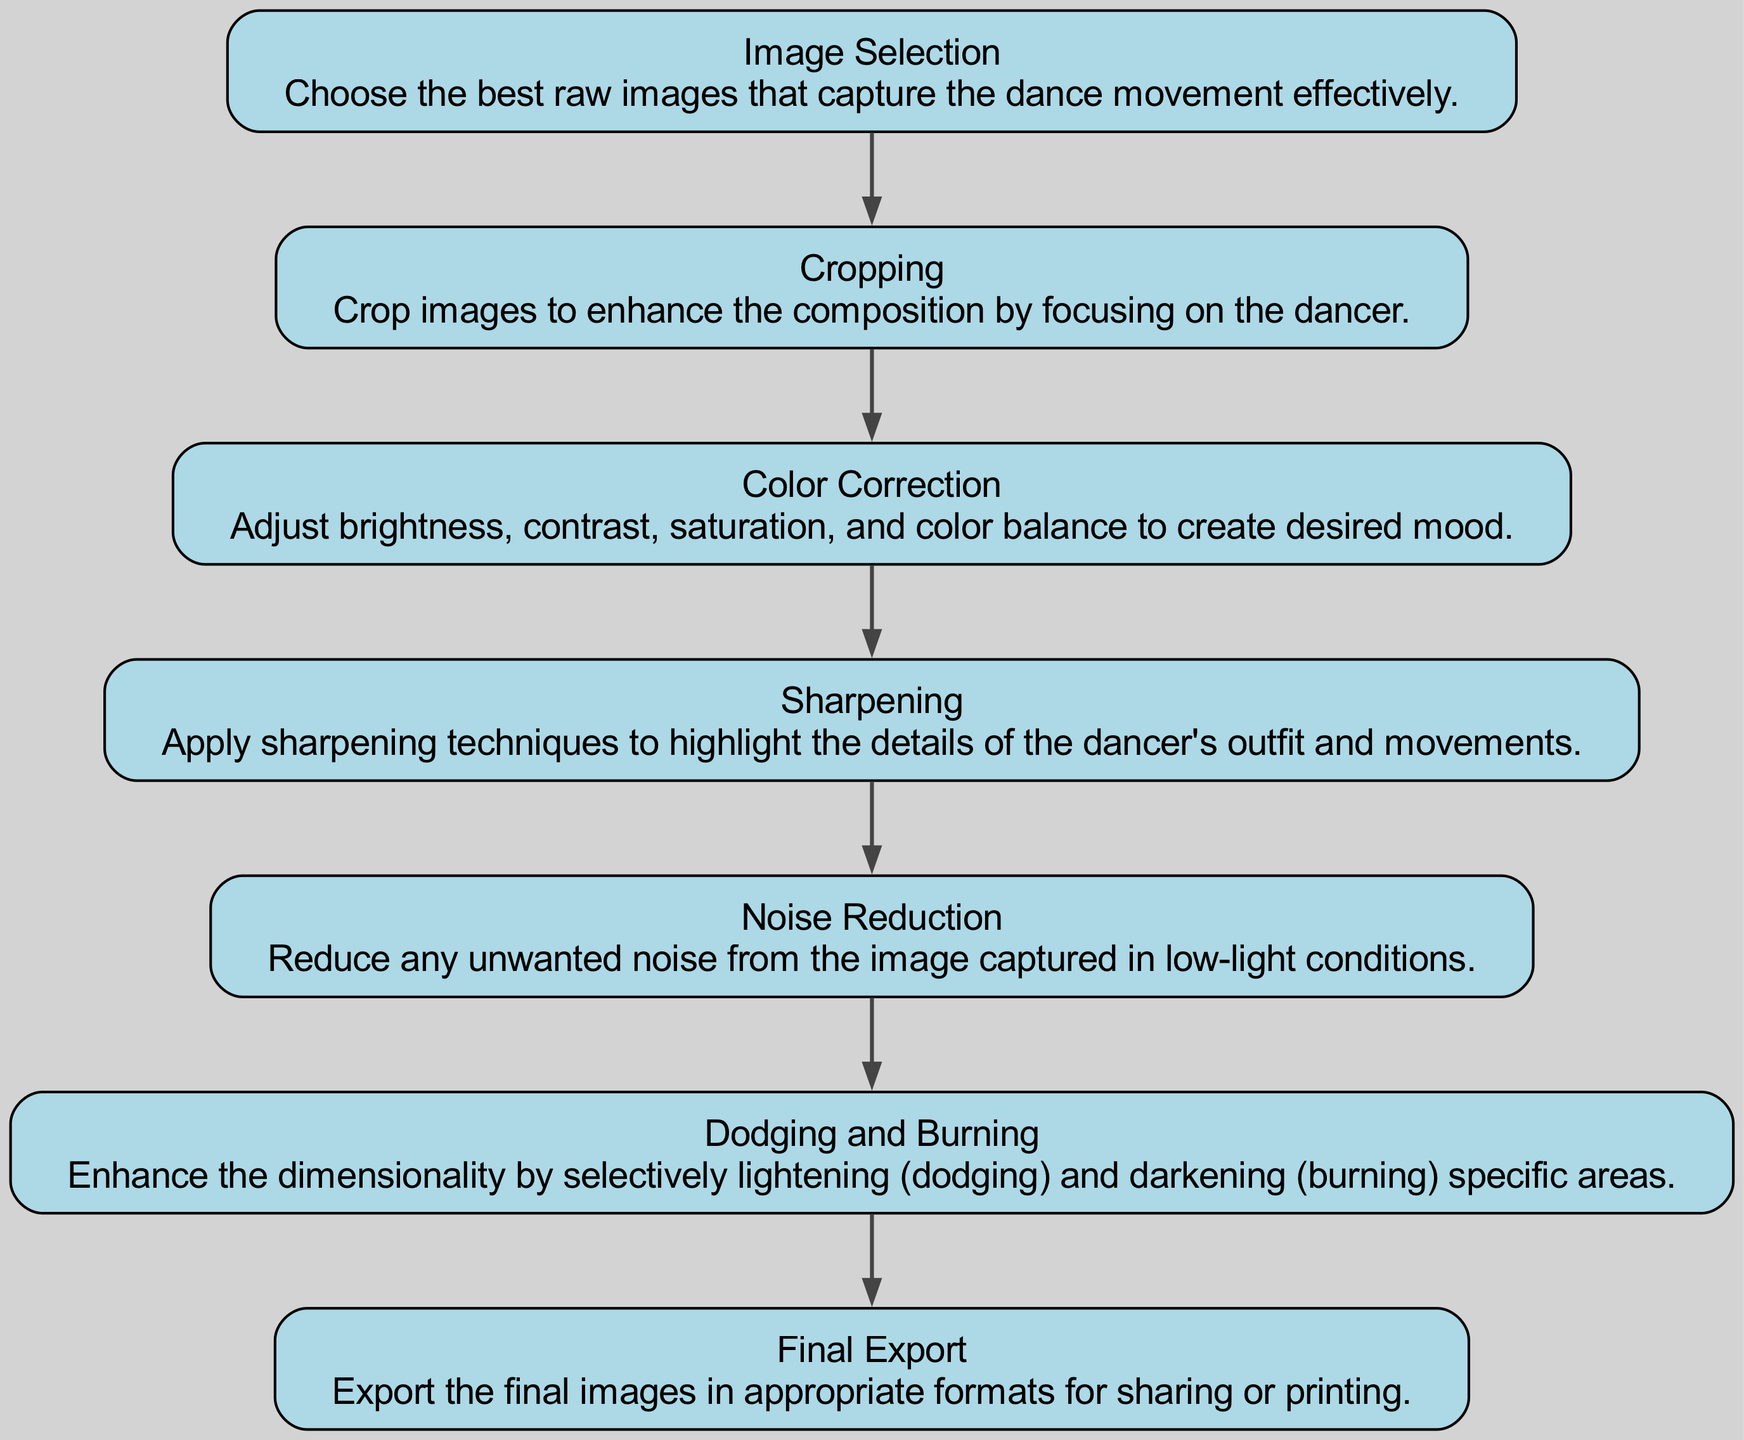What is the first step in the post-processing of dance images? The first step is "Image Selection," which involves choosing the best raw images that capture the dance movement effectively. This is indicated as the starting node in the directed graph.
Answer: Image Selection How many edges are there in the diagram? The diagram contains six edges, each demonstrating the flow from one post-processing step to the next. Counting each connection between the nodes confirms this total.
Answer: Six Which step comes after "Color Correction"? The step that follows "Color Correction" is "Sharpening," as seen by tracing the directed edge from "Color Correction" to "Sharpening."
Answer: Sharpening What is the final step in the post-processing workflow? The final step is "Final Export," as this node is the last in the directed graph, indicating that it is the concluding part of the process.
Answer: Final Export What technique is used to enhance dimensionality in the image? The technique used to enhance dimensionality is "Dodging and Burning," which is specifically focused on selectively lightening and darkening areas of the image to create depth.
Answer: Dodging and Burning What is the relationship between "Noise Reduction" and "Dodging and Burning"? The relationship is sequential: "Noise Reduction" comes before "Dodging and Burning," indicating that noise must be reduced before enhancing the dimensionality of the image. This is shown through the directed edge from "Noise Reduction" to "Dodging and Burning."
Answer: Sequential Which step directly follows "Sharpening"? "Noise Reduction" directly follows "Sharpening" in the workflow, as indicated by the arrow connecting the two nodes.
Answer: Noise Reduction In what order do the post-processing steps appear in the diagram? The order of the post-processing steps is: Image Selection, Cropping, Color Correction, Sharpening, Noise Reduction, Dodging and Burning, and Final Export. This is shown by following the directed edges from start to finish.
Answer: Image Selection, Cropping, Color Correction, Sharpening, Noise Reduction, Dodging and Burning, Final Export 